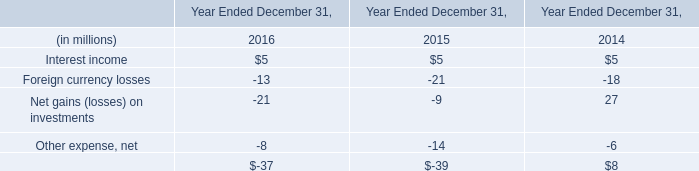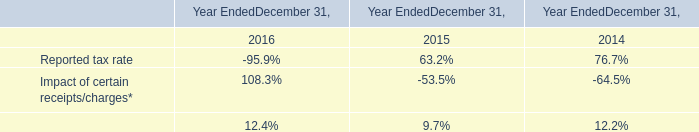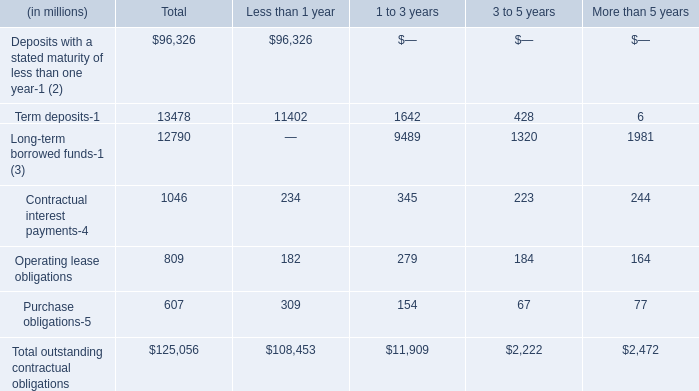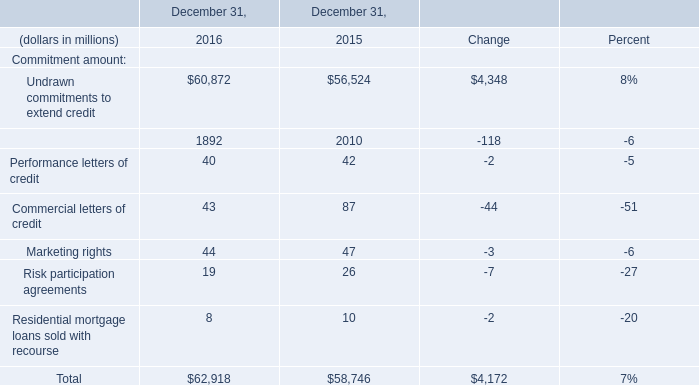What's the average of Term deposits of Less than 1 year, and Financial standby letters of credit of December 31, 2016 ? 
Computations: ((11402.0 + 1892.0) / 2)
Answer: 6647.0. 